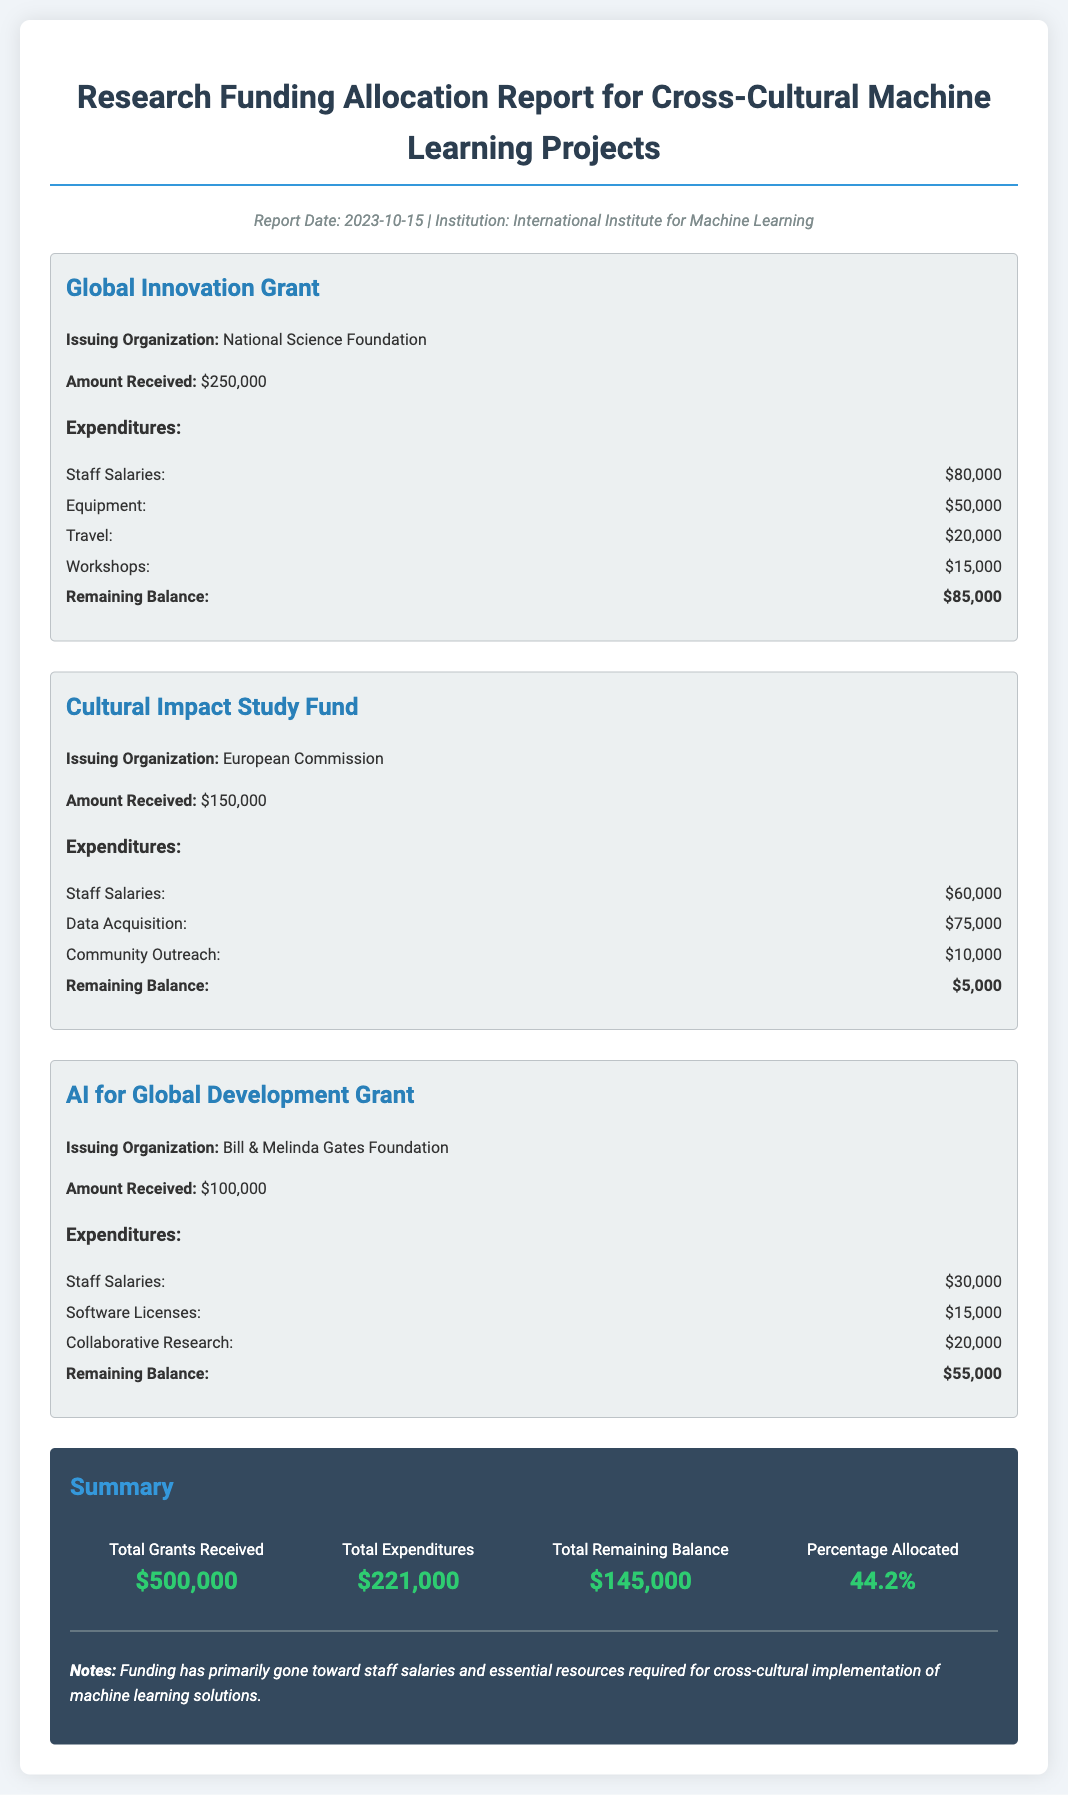What is the total amount received from grants? The total amount received is mentioned as the sum of all grants received in the document, which is $250,000 + $150,000 + $100,000.
Answer: $500,000 Who issued the Global Innovation Grant? The issuing organization for the Global Innovation Grant is specifically mentioned in the document.
Answer: National Science Foundation What is the total expenditure for the Cultural Impact Study Fund? The total expenditure for the Cultural Impact Study Fund can be calculated by adding up the expenditures listed in the document, which totals $60,000 + $75,000 + $10,000.
Answer: $145,000 What is the remaining balance for the AI for Global Development Grant? The remaining balance is provided directly in the expenditures section of the AI for Global Development Grant.
Answer: $55,000 What percentage of the total grants has been allocated? The percentage allocated is explicitly stated in the summary section of the document.
Answer: 44.2% Which organization provided funding for community outreach? The organization responsible for funding specific activities is listed alongside its respective expenditures in the document.
Answer: European Commission What was the largest single expenditure category listed? By checking the expenditures for all grants, it's determined that the largest is based on the values presented.
Answer: Data Acquisition What is the date of the report? The report date is mentioned at the top of the document, indicating when the information was compiled.
Answer: 2023-10-15 